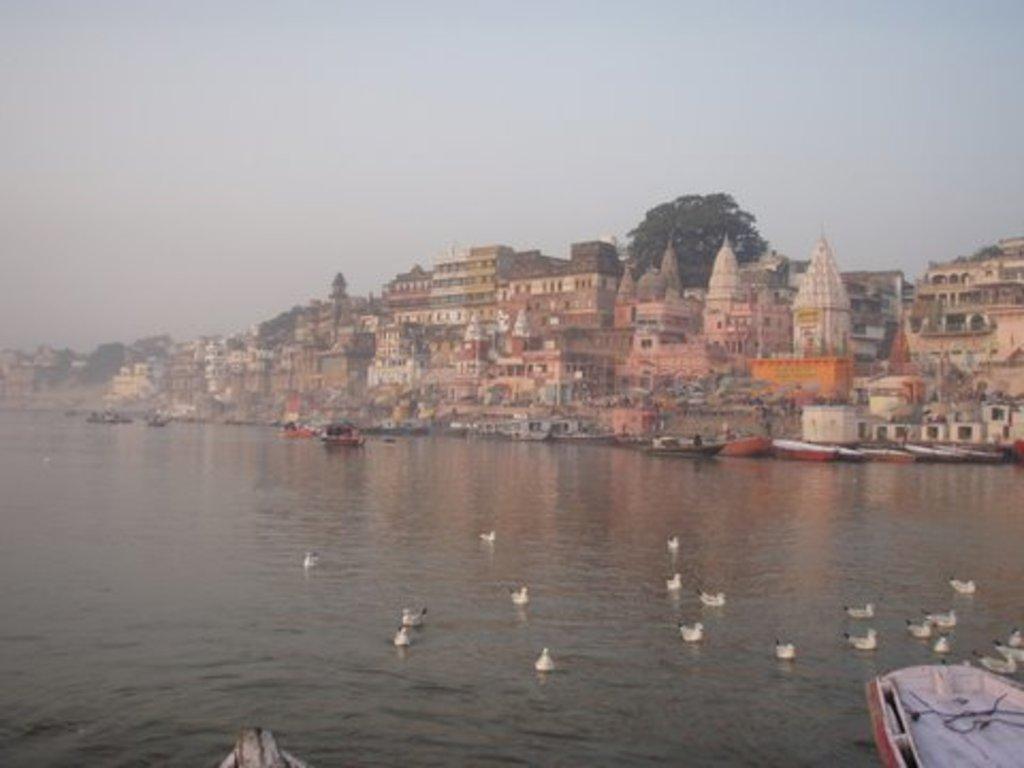How would you summarize this image in a sentence or two? This image consists of a water in which there are small ducks. To the right, there is a boat. In the background, there temples and buildings. 